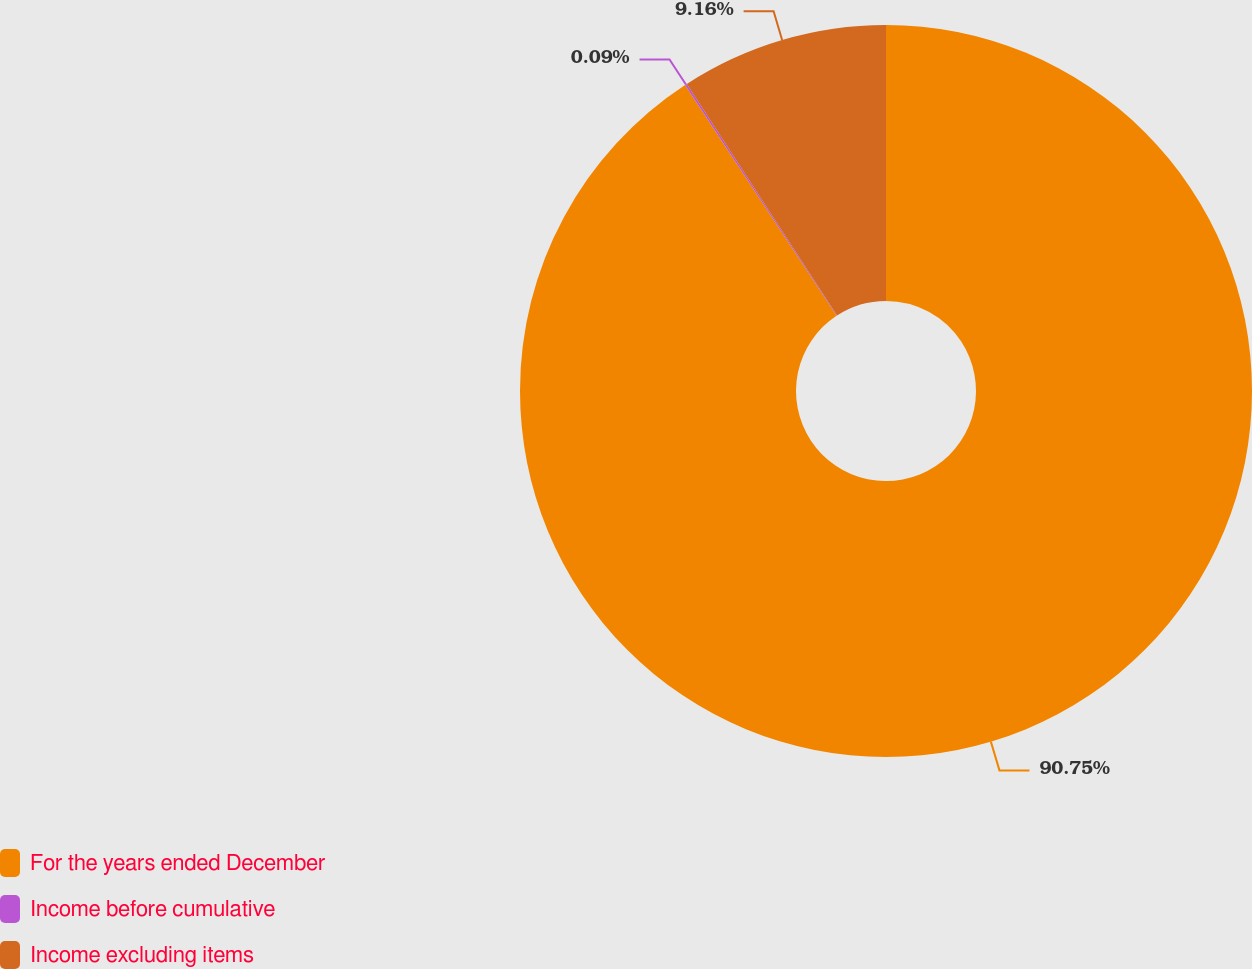<chart> <loc_0><loc_0><loc_500><loc_500><pie_chart><fcel>For the years ended December<fcel>Income before cumulative<fcel>Income excluding items<nl><fcel>90.75%<fcel>0.09%<fcel>9.16%<nl></chart> 